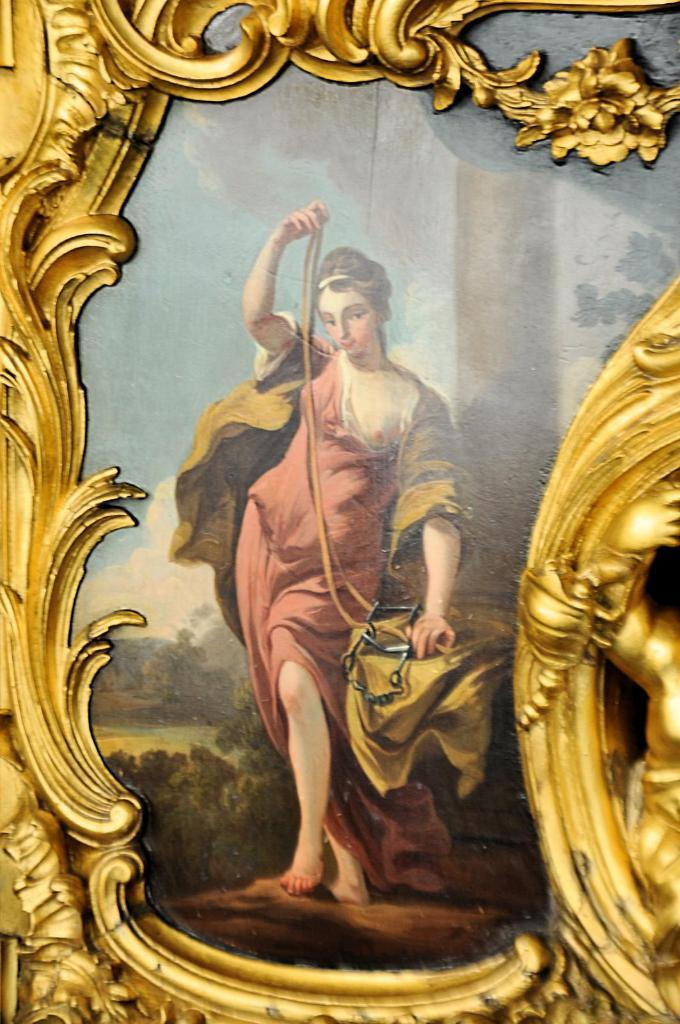What object is present in the image that typically holds a photograph? There is a photo frame in the image. What is the color of the photo frame? The photo frame is gold in color. Who is featured in the photo frame? There is a woman in the photo frame. What is the woman wearing in the photo? The woman is wearing a brown dress. How many coils can be seen in the image? There are no coils present in the image. What type of chickens are visible in the image? There are no chickens present in the image. 